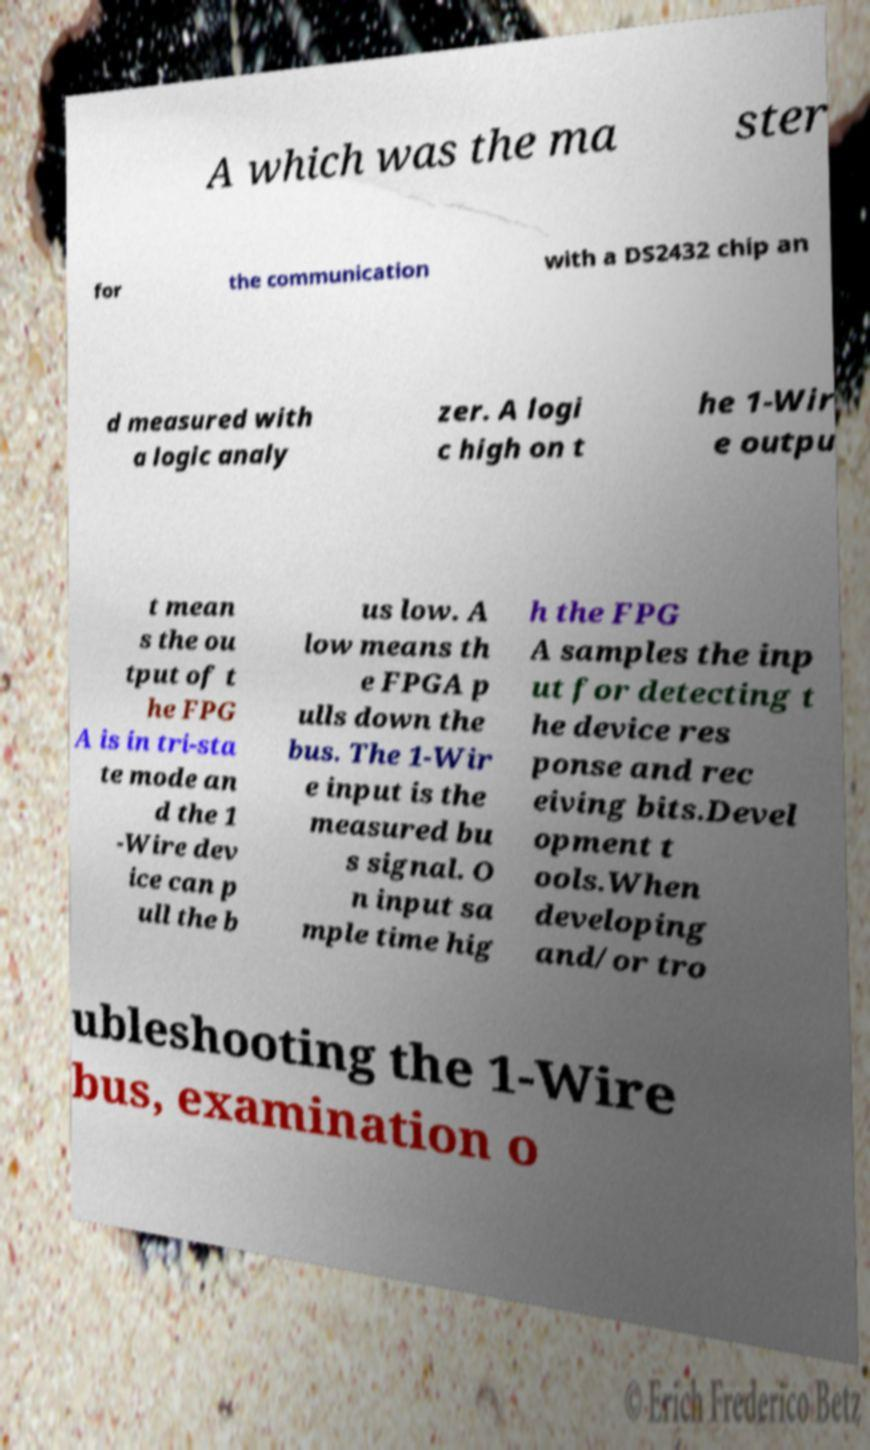For documentation purposes, I need the text within this image transcribed. Could you provide that? A which was the ma ster for the communication with a DS2432 chip an d measured with a logic analy zer. A logi c high on t he 1-Wir e outpu t mean s the ou tput of t he FPG A is in tri-sta te mode an d the 1 -Wire dev ice can p ull the b us low. A low means th e FPGA p ulls down the bus. The 1-Wir e input is the measured bu s signal. O n input sa mple time hig h the FPG A samples the inp ut for detecting t he device res ponse and rec eiving bits.Devel opment t ools.When developing and/or tro ubleshooting the 1-Wire bus, examination o 